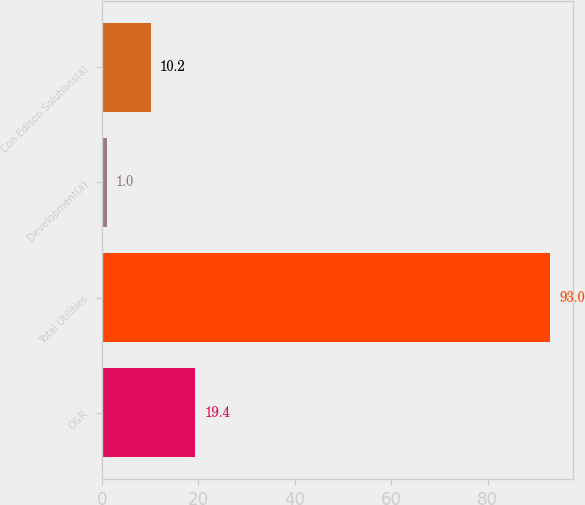Convert chart to OTSL. <chart><loc_0><loc_0><loc_500><loc_500><bar_chart><fcel>O&R<fcel>Total Utilities<fcel>Development(a)<fcel>Con Edison Solutions(a)<nl><fcel>19.4<fcel>93<fcel>1<fcel>10.2<nl></chart> 